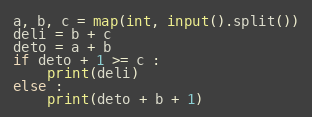<code> <loc_0><loc_0><loc_500><loc_500><_Python_>a, b, c = map(int, input().split())
deli = b + c
deto = a + b
if deto + 1 >= c :
    print(deli)
else :
    print(deto + b + 1)
</code> 